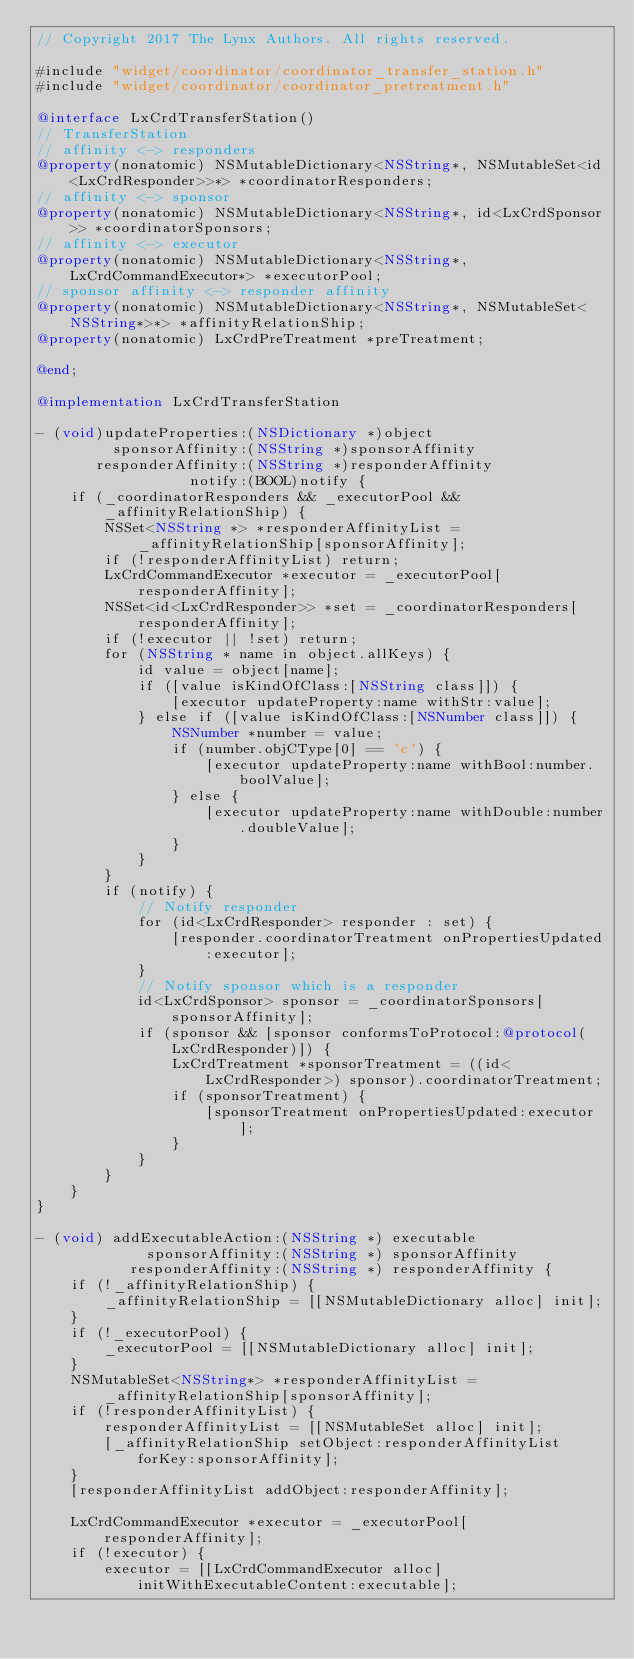<code> <loc_0><loc_0><loc_500><loc_500><_ObjectiveC_>// Copyright 2017 The Lynx Authors. All rights reserved.

#include "widget/coordinator/coordinator_transfer_station.h"
#include "widget/coordinator/coordinator_pretreatment.h"

@interface LxCrdTransferStation()
// TransferStation
// affinity <-> responders
@property(nonatomic) NSMutableDictionary<NSString*, NSMutableSet<id<LxCrdResponder>>*> *coordinatorResponders;
// affinity <-> sponsor
@property(nonatomic) NSMutableDictionary<NSString*, id<LxCrdSponsor>> *coordinatorSponsors;
// affinity <-> executor
@property(nonatomic) NSMutableDictionary<NSString*, LxCrdCommandExecutor*> *executorPool;
// sponsor affinity <-> responder affinity
@property(nonatomic) NSMutableDictionary<NSString*, NSMutableSet<NSString*>*> *affinityRelationShip;
@property(nonatomic) LxCrdPreTreatment *preTreatment;

@end;

@implementation LxCrdTransferStation

- (void)updateProperties:(NSDictionary *)object
         sponsorAffinity:(NSString *)sponsorAffinity
       responderAffinity:(NSString *)responderAffinity
                  notify:(BOOL)notify {
    if (_coordinatorResponders && _executorPool && _affinityRelationShip) {
        NSSet<NSString *> *responderAffinityList = _affinityRelationShip[sponsorAffinity];
        if (!responderAffinityList) return;
        LxCrdCommandExecutor *executor = _executorPool[responderAffinity];
        NSSet<id<LxCrdResponder>> *set = _coordinatorResponders[responderAffinity];
        if (!executor || !set) return;
        for (NSString * name in object.allKeys) {
            id value = object[name];
            if ([value isKindOfClass:[NSString class]]) {
                [executor updateProperty:name withStr:value];
            } else if ([value isKindOfClass:[NSNumber class]]) {
                NSNumber *number = value;
                if (number.objCType[0] == 'c') {
                    [executor updateProperty:name withBool:number.boolValue];
                } else {
                    [executor updateProperty:name withDouble:number.doubleValue];
                }
            }
        }
        if (notify) {
            // Notify responder
            for (id<LxCrdResponder> responder : set) {
                [responder.coordinatorTreatment onPropertiesUpdated:executor];
            }
            // Notify sponsor which is a responder
            id<LxCrdSponsor> sponsor = _coordinatorSponsors[sponsorAffinity];
            if (sponsor && [sponsor conformsToProtocol:@protocol(LxCrdResponder)]) {
                LxCrdTreatment *sponsorTreatment = ((id<LxCrdResponder>) sponsor).coordinatorTreatment;
                if (sponsorTreatment) {
                    [sponsorTreatment onPropertiesUpdated:executor];
                }
            }
        }
    }
}

- (void) addExecutableAction:(NSString *) executable
             sponsorAffinity:(NSString *) sponsorAffinity
           responderAffinity:(NSString *) responderAffinity {
    if (!_affinityRelationShip) {
        _affinityRelationShip = [[NSMutableDictionary alloc] init];
    }
    if (!_executorPool) {
        _executorPool = [[NSMutableDictionary alloc] init];
    }
    NSMutableSet<NSString*> *responderAffinityList = _affinityRelationShip[sponsorAffinity];
    if (!responderAffinityList) {
        responderAffinityList = [[NSMutableSet alloc] init];
        [_affinityRelationShip setObject:responderAffinityList forKey:sponsorAffinity];
    }
    [responderAffinityList addObject:responderAffinity];
    
    LxCrdCommandExecutor *executor = _executorPool[responderAffinity];
    if (!executor) {
        executor = [[LxCrdCommandExecutor alloc] initWithExecutableContent:executable];</code> 